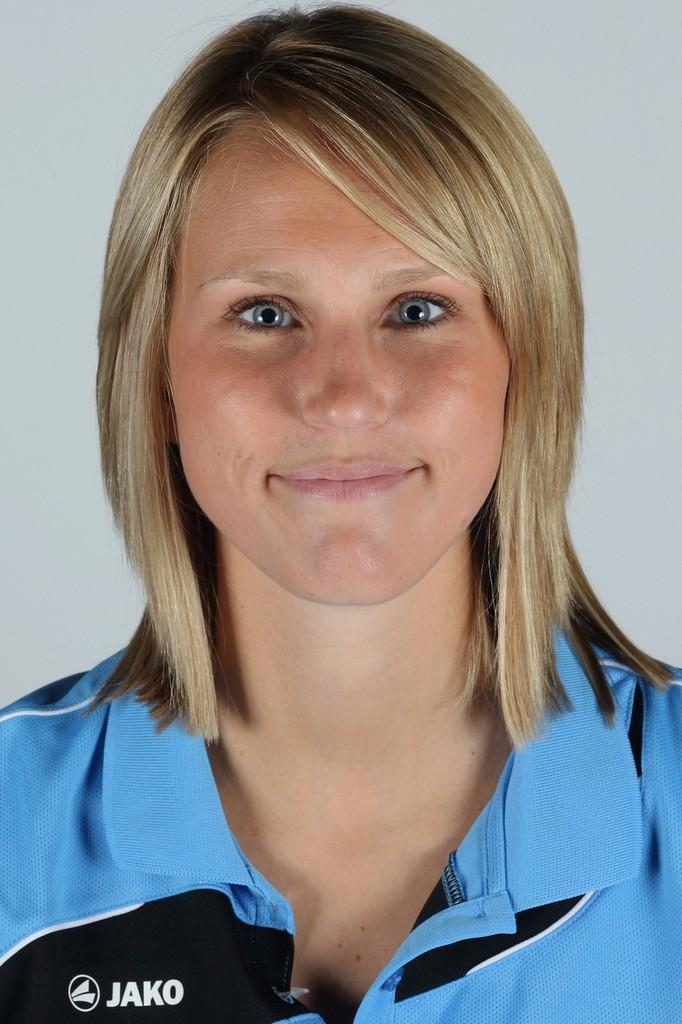<image>
Provide a brief description of the given image. A woman in a blue and black shirt has the Jako logo on her shirt. 